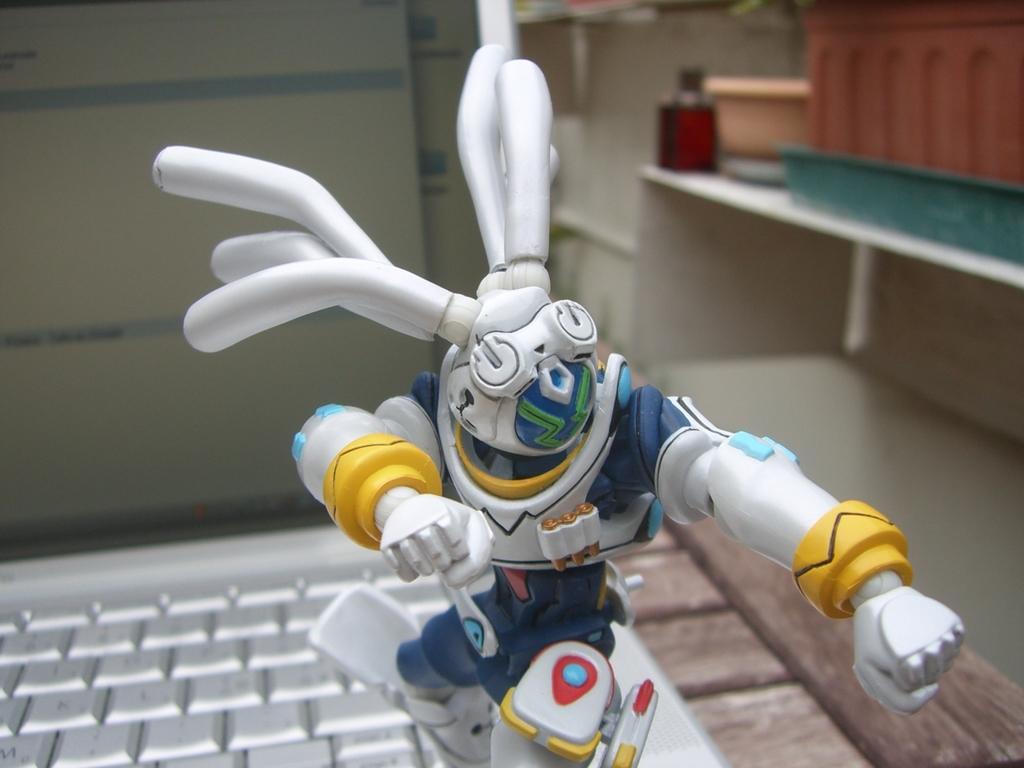In one or two sentences, can you explain what this image depicts? In this image there is there is one robot toy at bottom of this image which is in white color. There is one shelf at right side of this image and there is one laptop at left side of this image which is in white color. 